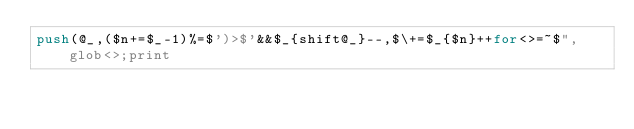Convert code to text. <code><loc_0><loc_0><loc_500><loc_500><_Perl_>push(@_,($n+=$_-1)%=$')>$'&&$_{shift@_}--,$\+=$_{$n}++for<>=~$",glob<>;print</code> 